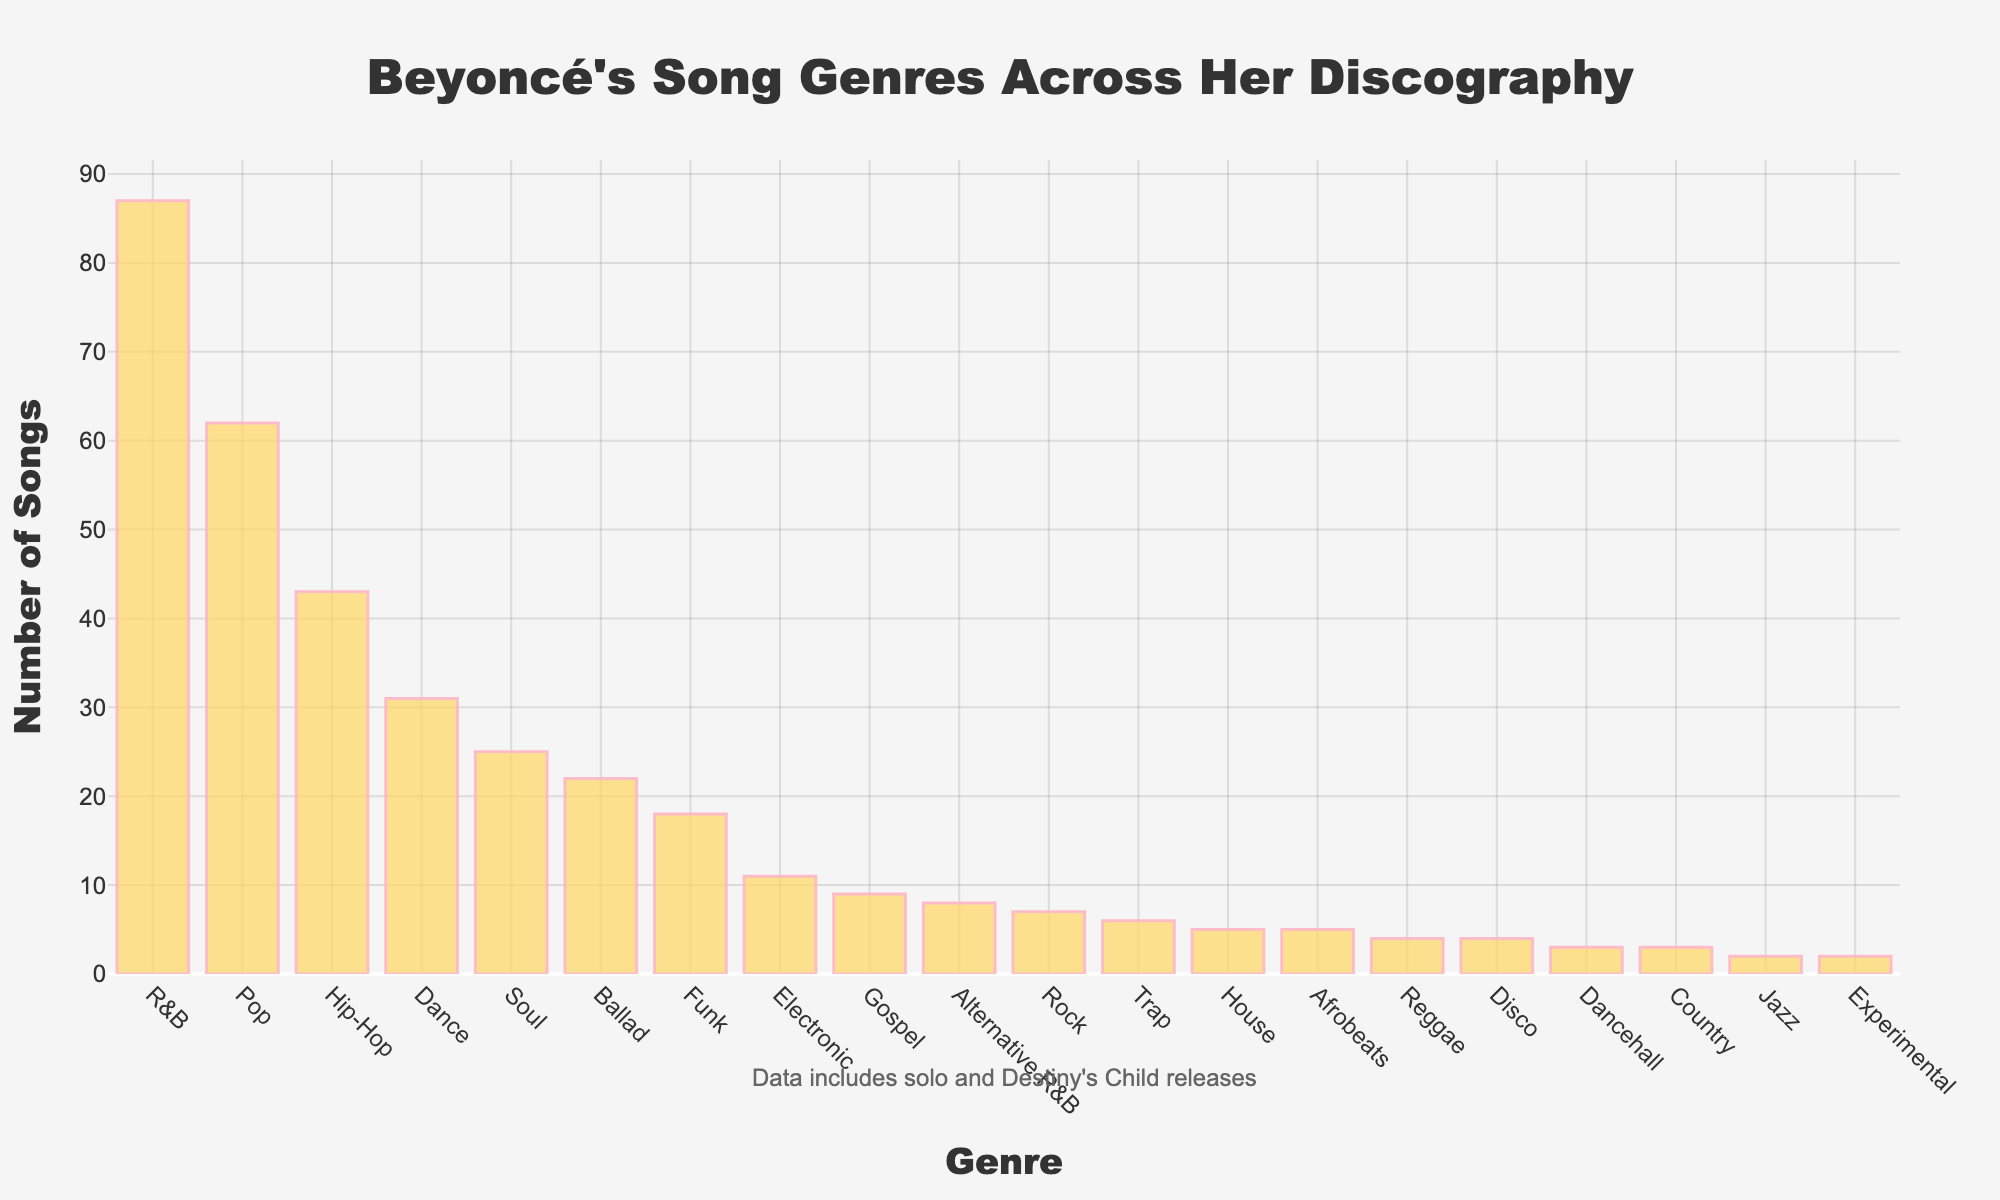Which genre has the highest number of songs? The tallest bar in the bar chart represents the genre with the highest number of songs.
Answer: R&B Which genre has exactly two songs? Look for the shortest bars on the chart. Only one bar corresponds to two songs.
Answer: Jazz and Experimental Which genre has more songs, Hip-Hop or Pop? Compare the heights of the bars for Hip-Hop and Pop. The bar for Pop is taller.
Answer: Pop What is the total number of songs for Soul and Funk combined? Sum the number of songs for Soul and Funk: 25 (Soul) + 18 (Funk) = 43.
Answer: 43 What is the difference in the number of songs between the highest and lowest genres? The genre with the most songs is R&B (87), and the genres with the fewest songs are Jazz and Experimental (2 each). The difference is 87 - 2 = 85.
Answer: 85 Does Pop have less than or more than double the number of songs as Dance? Pop has 62 songs and Dance has 31. Since 62 is exactly double 31, Pop has exactly double the number of songs as Dance.
Answer: Double How many genres have more than 20 songs? Identify and count all the bars higher than 20 on the y-axis: R&B, Pop, Hip-Hop, and Soul. There are 4 genres.
Answer: 4 Is the number of Gospel songs greater than 10? The bar for Gospel is below 10 on the y-axis, so it’s less than 10.
Answer: No What is the combined number of songs for genres with less than 10 songs? Sum the numbers for Gospel (9), Rock (7), Country (3), Afrobeats (5), Reggae (4), Jazz (2), Trap (6), Disco (4), Dancehall (3), House (5), and Experimental (2): 50
Answer: 50 Which genre has the closest number of songs to Alternative R&B? Alternative R&B has 8 songs. Trap has 6 songs, which is the closest.
Answer: Trap 